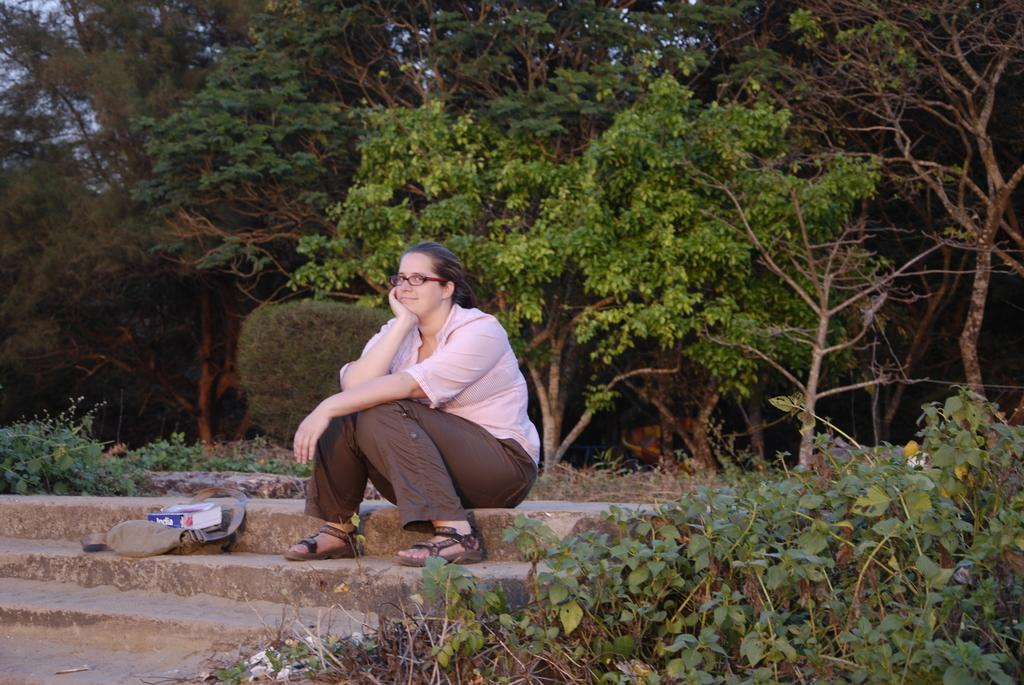Who is the main subject in the image? There is a woman in the image. What is the woman doing in the image? The woman is posing for a camera. What accessory is the woman wearing in the image? The woman is wearing spectacles. What items can be seen near the woman in the image? There is a bag and a book in the image. What type of vegetation is present in the image? There are plants in the image. What can be seen in the background of the image? There are trees and the sky visible in the background of the image. How many cats are sitting on the pear in the image? There are no cats or pears present in the image. 